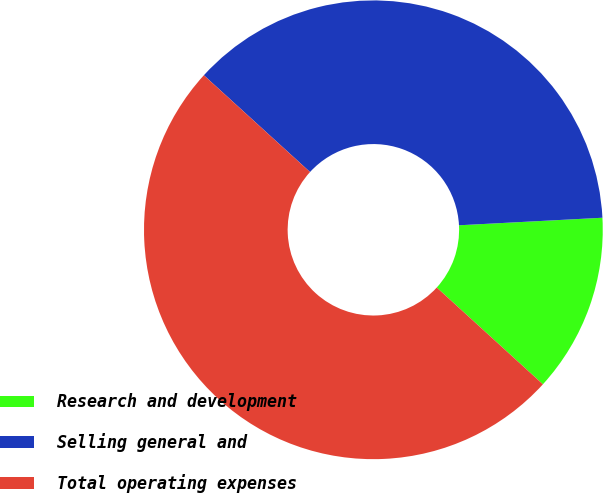Convert chart to OTSL. <chart><loc_0><loc_0><loc_500><loc_500><pie_chart><fcel>Research and development<fcel>Selling general and<fcel>Total operating expenses<nl><fcel>12.6%<fcel>37.4%<fcel>50.0%<nl></chart> 